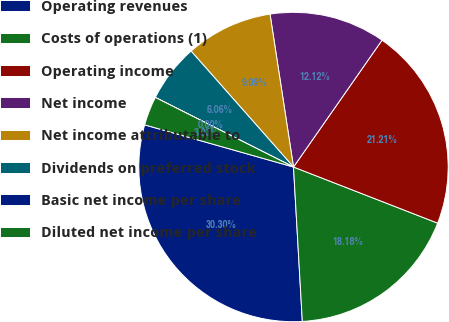Convert chart to OTSL. <chart><loc_0><loc_0><loc_500><loc_500><pie_chart><fcel>Operating revenues<fcel>Costs of operations (1)<fcel>Operating income<fcel>Net income<fcel>Net income attributable to<fcel>Dividends on preferred stock<fcel>Basic net income per share<fcel>Diluted net income per share<nl><fcel>30.3%<fcel>18.18%<fcel>21.21%<fcel>12.12%<fcel>9.09%<fcel>6.06%<fcel>0.0%<fcel>3.03%<nl></chart> 